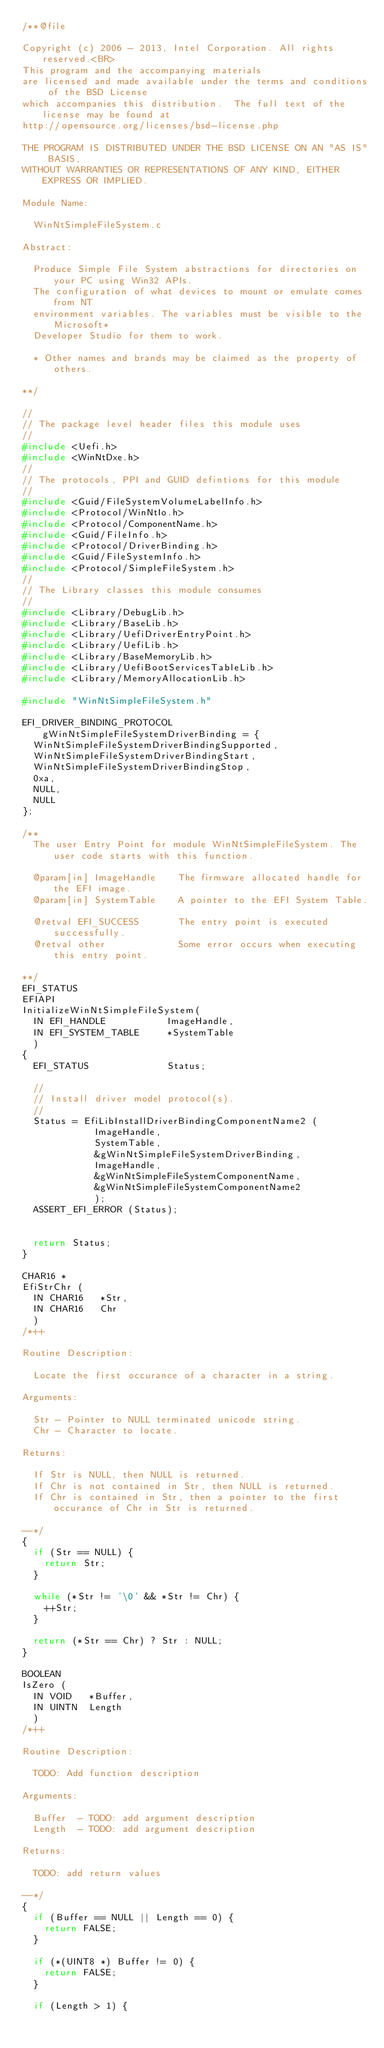Convert code to text. <code><loc_0><loc_0><loc_500><loc_500><_C_>/**@file

Copyright (c) 2006 - 2013, Intel Corporation. All rights reserved.<BR>
This program and the accompanying materials
are licensed and made available under the terms and conditions of the BSD License
which accompanies this distribution.  The full text of the license may be found at
http://opensource.org/licenses/bsd-license.php

THE PROGRAM IS DISTRIBUTED UNDER THE BSD LICENSE ON AN "AS IS" BASIS,
WITHOUT WARRANTIES OR REPRESENTATIONS OF ANY KIND, EITHER EXPRESS OR IMPLIED.

Module Name:

  WinNtSimpleFileSystem.c

Abstract:

  Produce Simple File System abstractions for directories on your PC using Win32 APIs.
  The configuration of what devices to mount or emulate comes from NT
  environment variables. The variables must be visible to the Microsoft*
  Developer Studio for them to work.

  * Other names and brands may be claimed as the property of others.

**/

//
// The package level header files this module uses
//
#include <Uefi.h>
#include <WinNtDxe.h>
//
// The protocols, PPI and GUID defintions for this module
//
#include <Guid/FileSystemVolumeLabelInfo.h>
#include <Protocol/WinNtIo.h>
#include <Protocol/ComponentName.h>
#include <Guid/FileInfo.h>
#include <Protocol/DriverBinding.h>
#include <Guid/FileSystemInfo.h>
#include <Protocol/SimpleFileSystem.h>
//
// The Library classes this module consumes
//
#include <Library/DebugLib.h>
#include <Library/BaseLib.h>
#include <Library/UefiDriverEntryPoint.h>
#include <Library/UefiLib.h>
#include <Library/BaseMemoryLib.h>
#include <Library/UefiBootServicesTableLib.h>
#include <Library/MemoryAllocationLib.h>

#include "WinNtSimpleFileSystem.h"

EFI_DRIVER_BINDING_PROTOCOL gWinNtSimpleFileSystemDriverBinding = {
  WinNtSimpleFileSystemDriverBindingSupported,
  WinNtSimpleFileSystemDriverBindingStart,
  WinNtSimpleFileSystemDriverBindingStop,
  0xa,
  NULL,
  NULL
};

/**
  The user Entry Point for module WinNtSimpleFileSystem. The user code starts with this function.

  @param[in] ImageHandle    The firmware allocated handle for the EFI image.  
  @param[in] SystemTable    A pointer to the EFI System Table.
  
  @retval EFI_SUCCESS       The entry point is executed successfully.
  @retval other             Some error occurs when executing this entry point.

**/
EFI_STATUS
EFIAPI
InitializeWinNtSimpleFileSystem(
  IN EFI_HANDLE           ImageHandle,
  IN EFI_SYSTEM_TABLE     *SystemTable
  )
{
  EFI_STATUS              Status;

  //
  // Install driver model protocol(s).
  //
  Status = EfiLibInstallDriverBindingComponentName2 (
             ImageHandle,
             SystemTable,
             &gWinNtSimpleFileSystemDriverBinding,
             ImageHandle,
             &gWinNtSimpleFileSystemComponentName,
             &gWinNtSimpleFileSystemComponentName2
             );
  ASSERT_EFI_ERROR (Status);


  return Status;
}

CHAR16 *
EfiStrChr (
  IN CHAR16   *Str,
  IN CHAR16   Chr
  )
/*++

Routine Description:

  Locate the first occurance of a character in a string.

Arguments:

  Str - Pointer to NULL terminated unicode string.
  Chr - Character to locate.

Returns:

  If Str is NULL, then NULL is returned.
  If Chr is not contained in Str, then NULL is returned.
  If Chr is contained in Str, then a pointer to the first occurance of Chr in Str is returned.

--*/
{
  if (Str == NULL) {
    return Str;
  }

  while (*Str != '\0' && *Str != Chr) {
    ++Str;
  }

  return (*Str == Chr) ? Str : NULL;
}

BOOLEAN
IsZero (
  IN VOID   *Buffer,
  IN UINTN  Length
  )
/*++

Routine Description:

  TODO: Add function description

Arguments:

  Buffer  - TODO: add argument description
  Length  - TODO: add argument description

Returns:

  TODO: add return values

--*/
{
  if (Buffer == NULL || Length == 0) {
    return FALSE;
  }

  if (*(UINT8 *) Buffer != 0) {
    return FALSE;
  }

  if (Length > 1) {</code> 